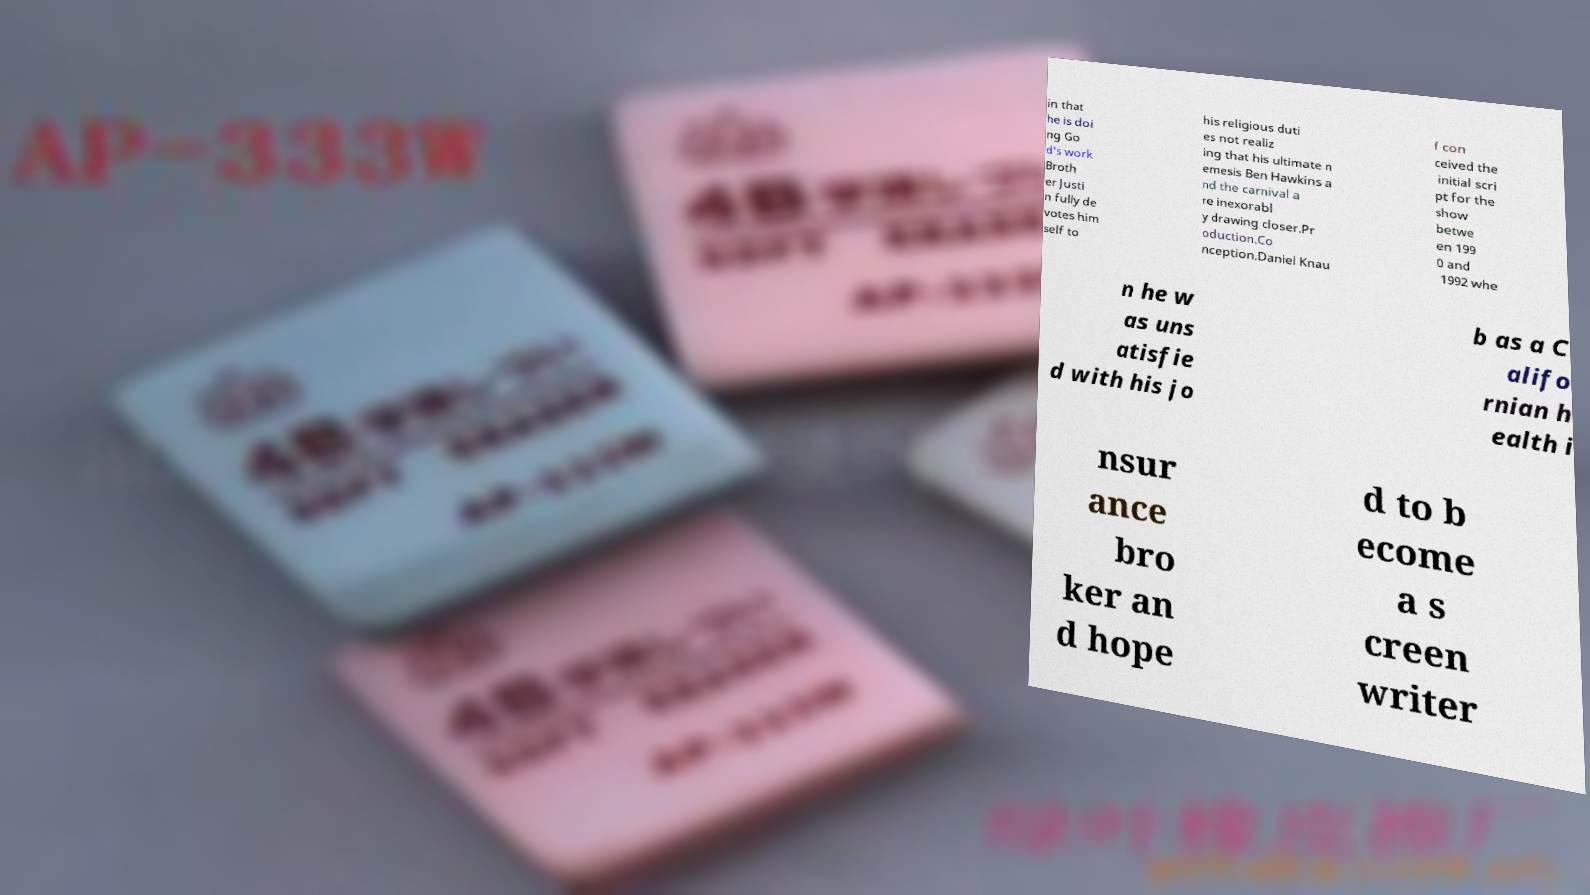For documentation purposes, I need the text within this image transcribed. Could you provide that? in that he is doi ng Go d's work Broth er Justi n fully de votes him self to his religious duti es not realiz ing that his ultimate n emesis Ben Hawkins a nd the carnival a re inexorabl y drawing closer.Pr oduction.Co nception.Daniel Knau f con ceived the initial scri pt for the show betwe en 199 0 and 1992 whe n he w as uns atisfie d with his jo b as a C alifo rnian h ealth i nsur ance bro ker an d hope d to b ecome a s creen writer 